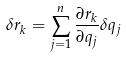Convert formula to latex. <formula><loc_0><loc_0><loc_500><loc_500>\delta r _ { k } = \sum _ { j = 1 } ^ { n } \frac { \partial r _ { k } } { \partial q _ { j } } \delta q _ { j }</formula> 